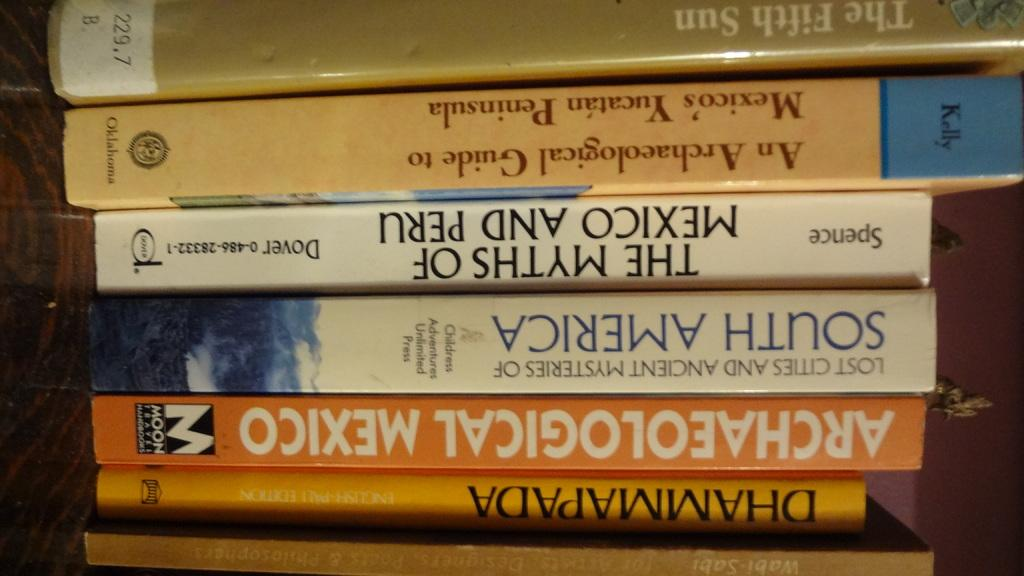What type of objects can be seen in the image? There are books and a wooden object in the image. What is the background of the image? There is a wall in the image. What type of nut is hanging from the wooden object in the image? There is no nut hanging from the wooden object in the image. How much sugar is visible on the books in the image? There is no sugar present on the books in the image. 